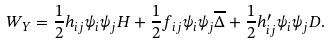Convert formula to latex. <formula><loc_0><loc_0><loc_500><loc_500>W _ { Y } = \frac { 1 } { 2 } h _ { i j } \psi _ { i } \psi _ { j } H + \frac { 1 } { 2 } f _ { i j } \psi _ { i } \psi _ { j } \overline { \Delta } + \frac { 1 } { 2 } h ^ { \prime } _ { i j } \psi _ { i } \psi _ { j } D .</formula> 